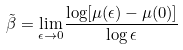<formula> <loc_0><loc_0><loc_500><loc_500>\tilde { \beta } = \underset { \epsilon \rightarrow 0 } { \lim } { \frac { \log [ \mu ( \epsilon ) - \mu ( 0 ) ] } { \log \epsilon } }</formula> 